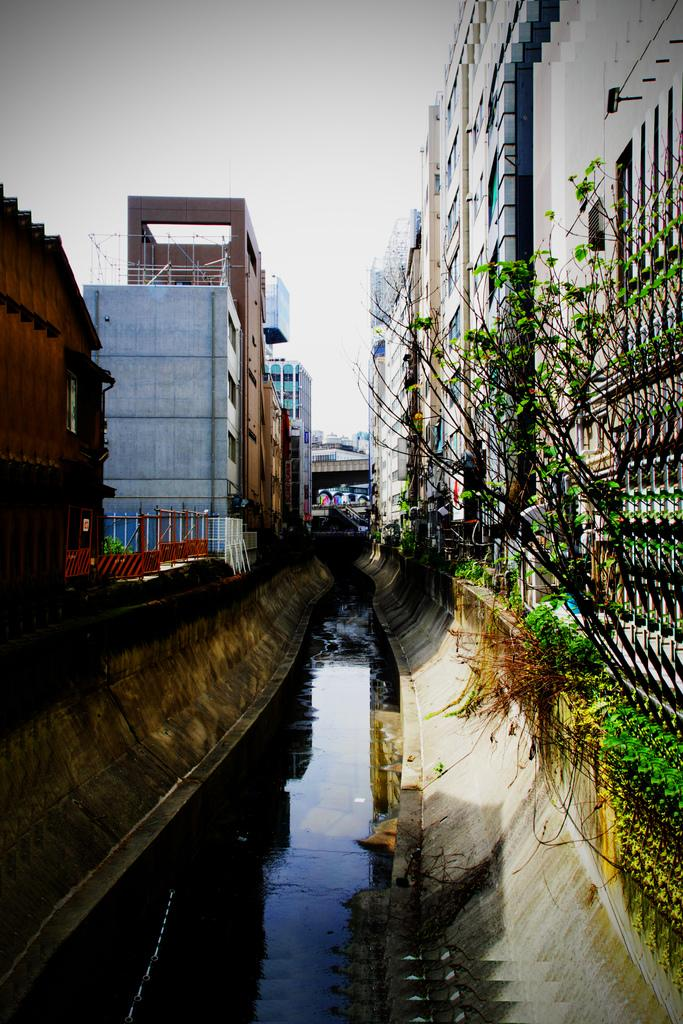What is visible in the image? There is water visible in the image. What can be seen on the left side of the image? There are buildings on the left side of the image. What can be seen on the right side of the image? There are buildings on the right side of the image. What is visible at the top of the image? The sky is visible at the top of the image. Can you see your nose in the image? Your nose is not present in the image, as it is a photograph or illustration of a scene or landscape. 